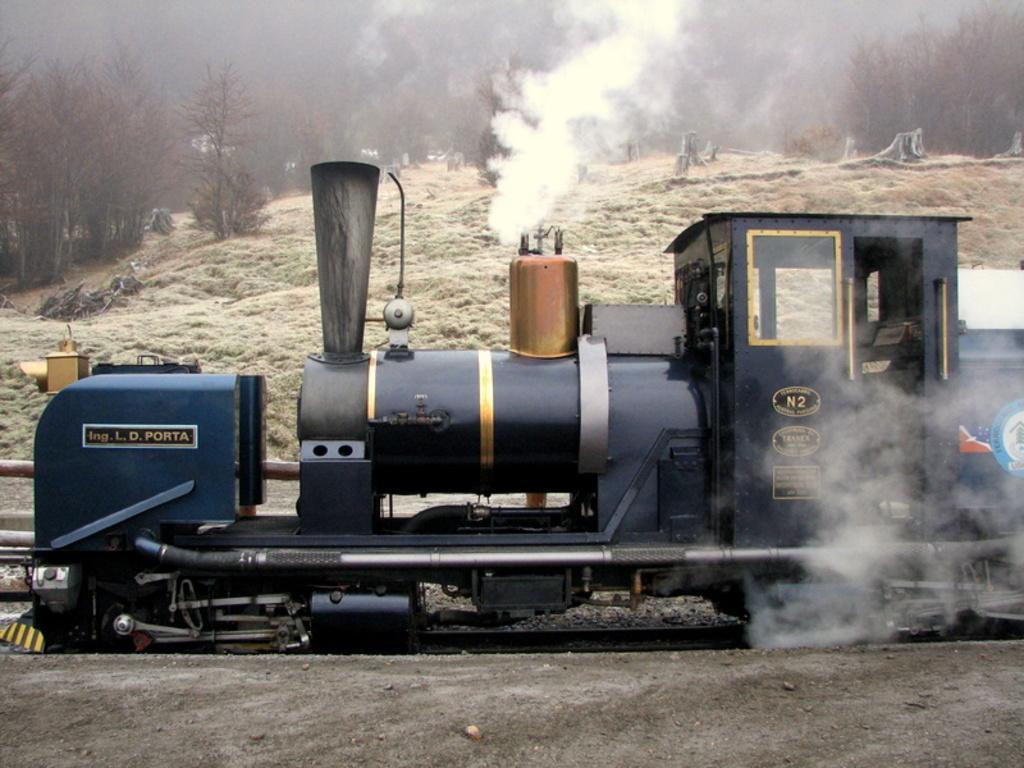How would you summarize this image in a sentence or two? In this image in the center there is an engine of the rail with some text written on it. In the background there are trees and there is smoke. 